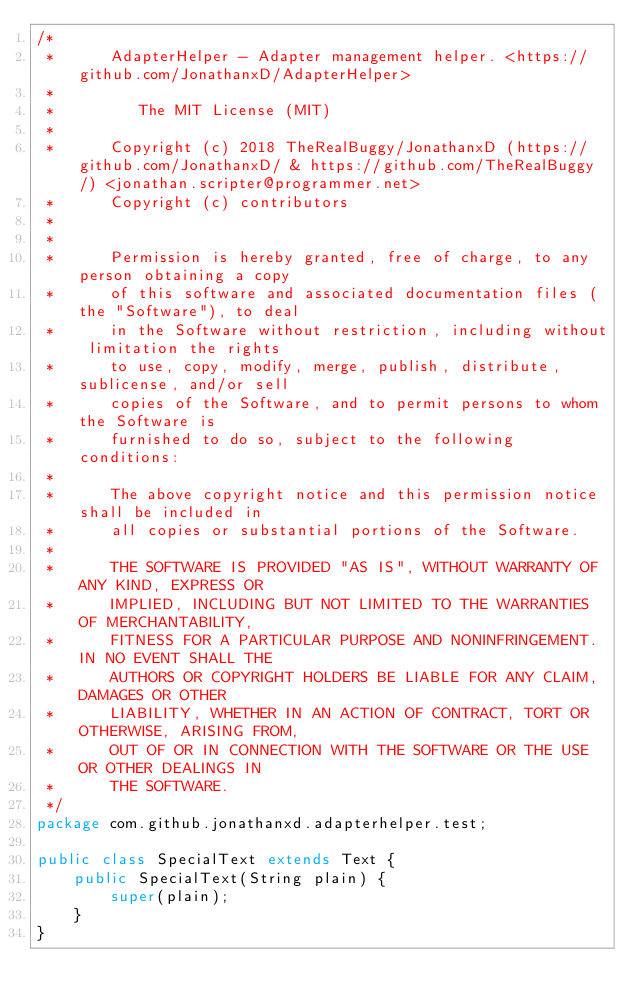<code> <loc_0><loc_0><loc_500><loc_500><_Java_>/*
 *      AdapterHelper - Adapter management helper. <https://github.com/JonathanxD/AdapterHelper>
 *
 *         The MIT License (MIT)
 *
 *      Copyright (c) 2018 TheRealBuggy/JonathanxD (https://github.com/JonathanxD/ & https://github.com/TheRealBuggy/) <jonathan.scripter@programmer.net>
 *      Copyright (c) contributors
 *
 *
 *      Permission is hereby granted, free of charge, to any person obtaining a copy
 *      of this software and associated documentation files (the "Software"), to deal
 *      in the Software without restriction, including without limitation the rights
 *      to use, copy, modify, merge, publish, distribute, sublicense, and/or sell
 *      copies of the Software, and to permit persons to whom the Software is
 *      furnished to do so, subject to the following conditions:
 *
 *      The above copyright notice and this permission notice shall be included in
 *      all copies or substantial portions of the Software.
 *
 *      THE SOFTWARE IS PROVIDED "AS IS", WITHOUT WARRANTY OF ANY KIND, EXPRESS OR
 *      IMPLIED, INCLUDING BUT NOT LIMITED TO THE WARRANTIES OF MERCHANTABILITY,
 *      FITNESS FOR A PARTICULAR PURPOSE AND NONINFRINGEMENT. IN NO EVENT SHALL THE
 *      AUTHORS OR COPYRIGHT HOLDERS BE LIABLE FOR ANY CLAIM, DAMAGES OR OTHER
 *      LIABILITY, WHETHER IN AN ACTION OF CONTRACT, TORT OR OTHERWISE, ARISING FROM,
 *      OUT OF OR IN CONNECTION WITH THE SOFTWARE OR THE USE OR OTHER DEALINGS IN
 *      THE SOFTWARE.
 */
package com.github.jonathanxd.adapterhelper.test;

public class SpecialText extends Text {
    public SpecialText(String plain) {
        super(plain);
    }
}
</code> 